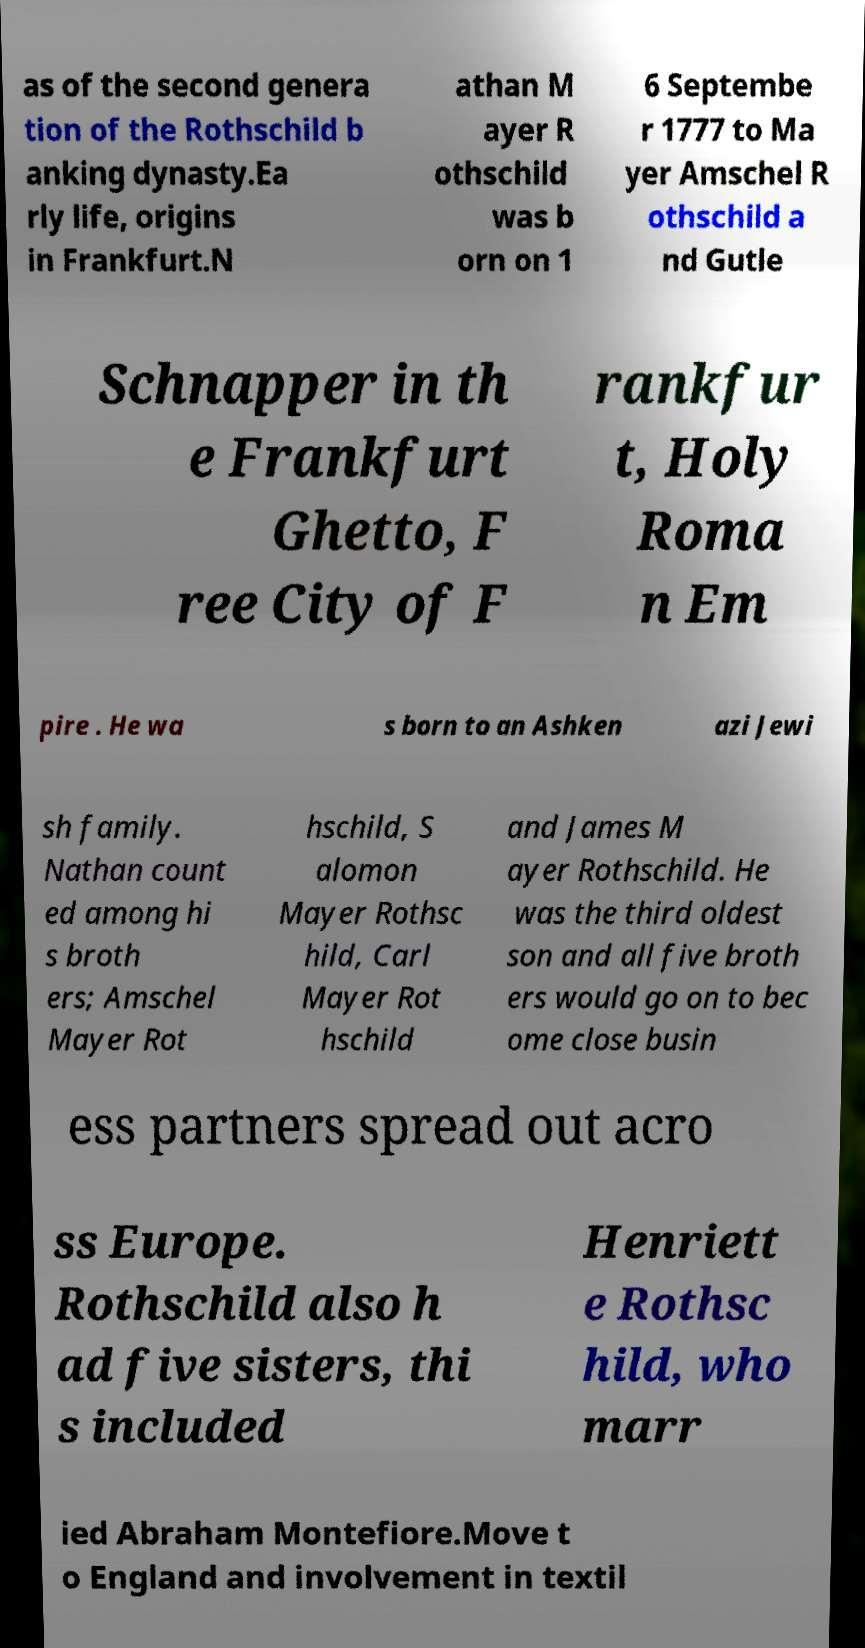Can you read and provide the text displayed in the image?This photo seems to have some interesting text. Can you extract and type it out for me? as of the second genera tion of the Rothschild b anking dynasty.Ea rly life, origins in Frankfurt.N athan M ayer R othschild was b orn on 1 6 Septembe r 1777 to Ma yer Amschel R othschild a nd Gutle Schnapper in th e Frankfurt Ghetto, F ree City of F rankfur t, Holy Roma n Em pire . He wa s born to an Ashken azi Jewi sh family. Nathan count ed among hi s broth ers; Amschel Mayer Rot hschild, S alomon Mayer Rothsc hild, Carl Mayer Rot hschild and James M ayer Rothschild. He was the third oldest son and all five broth ers would go on to bec ome close busin ess partners spread out acro ss Europe. Rothschild also h ad five sisters, thi s included Henriett e Rothsc hild, who marr ied Abraham Montefiore.Move t o England and involvement in textil 